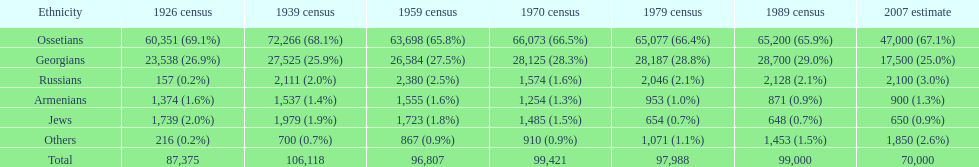What is the count of existing ethnicities? 6. 